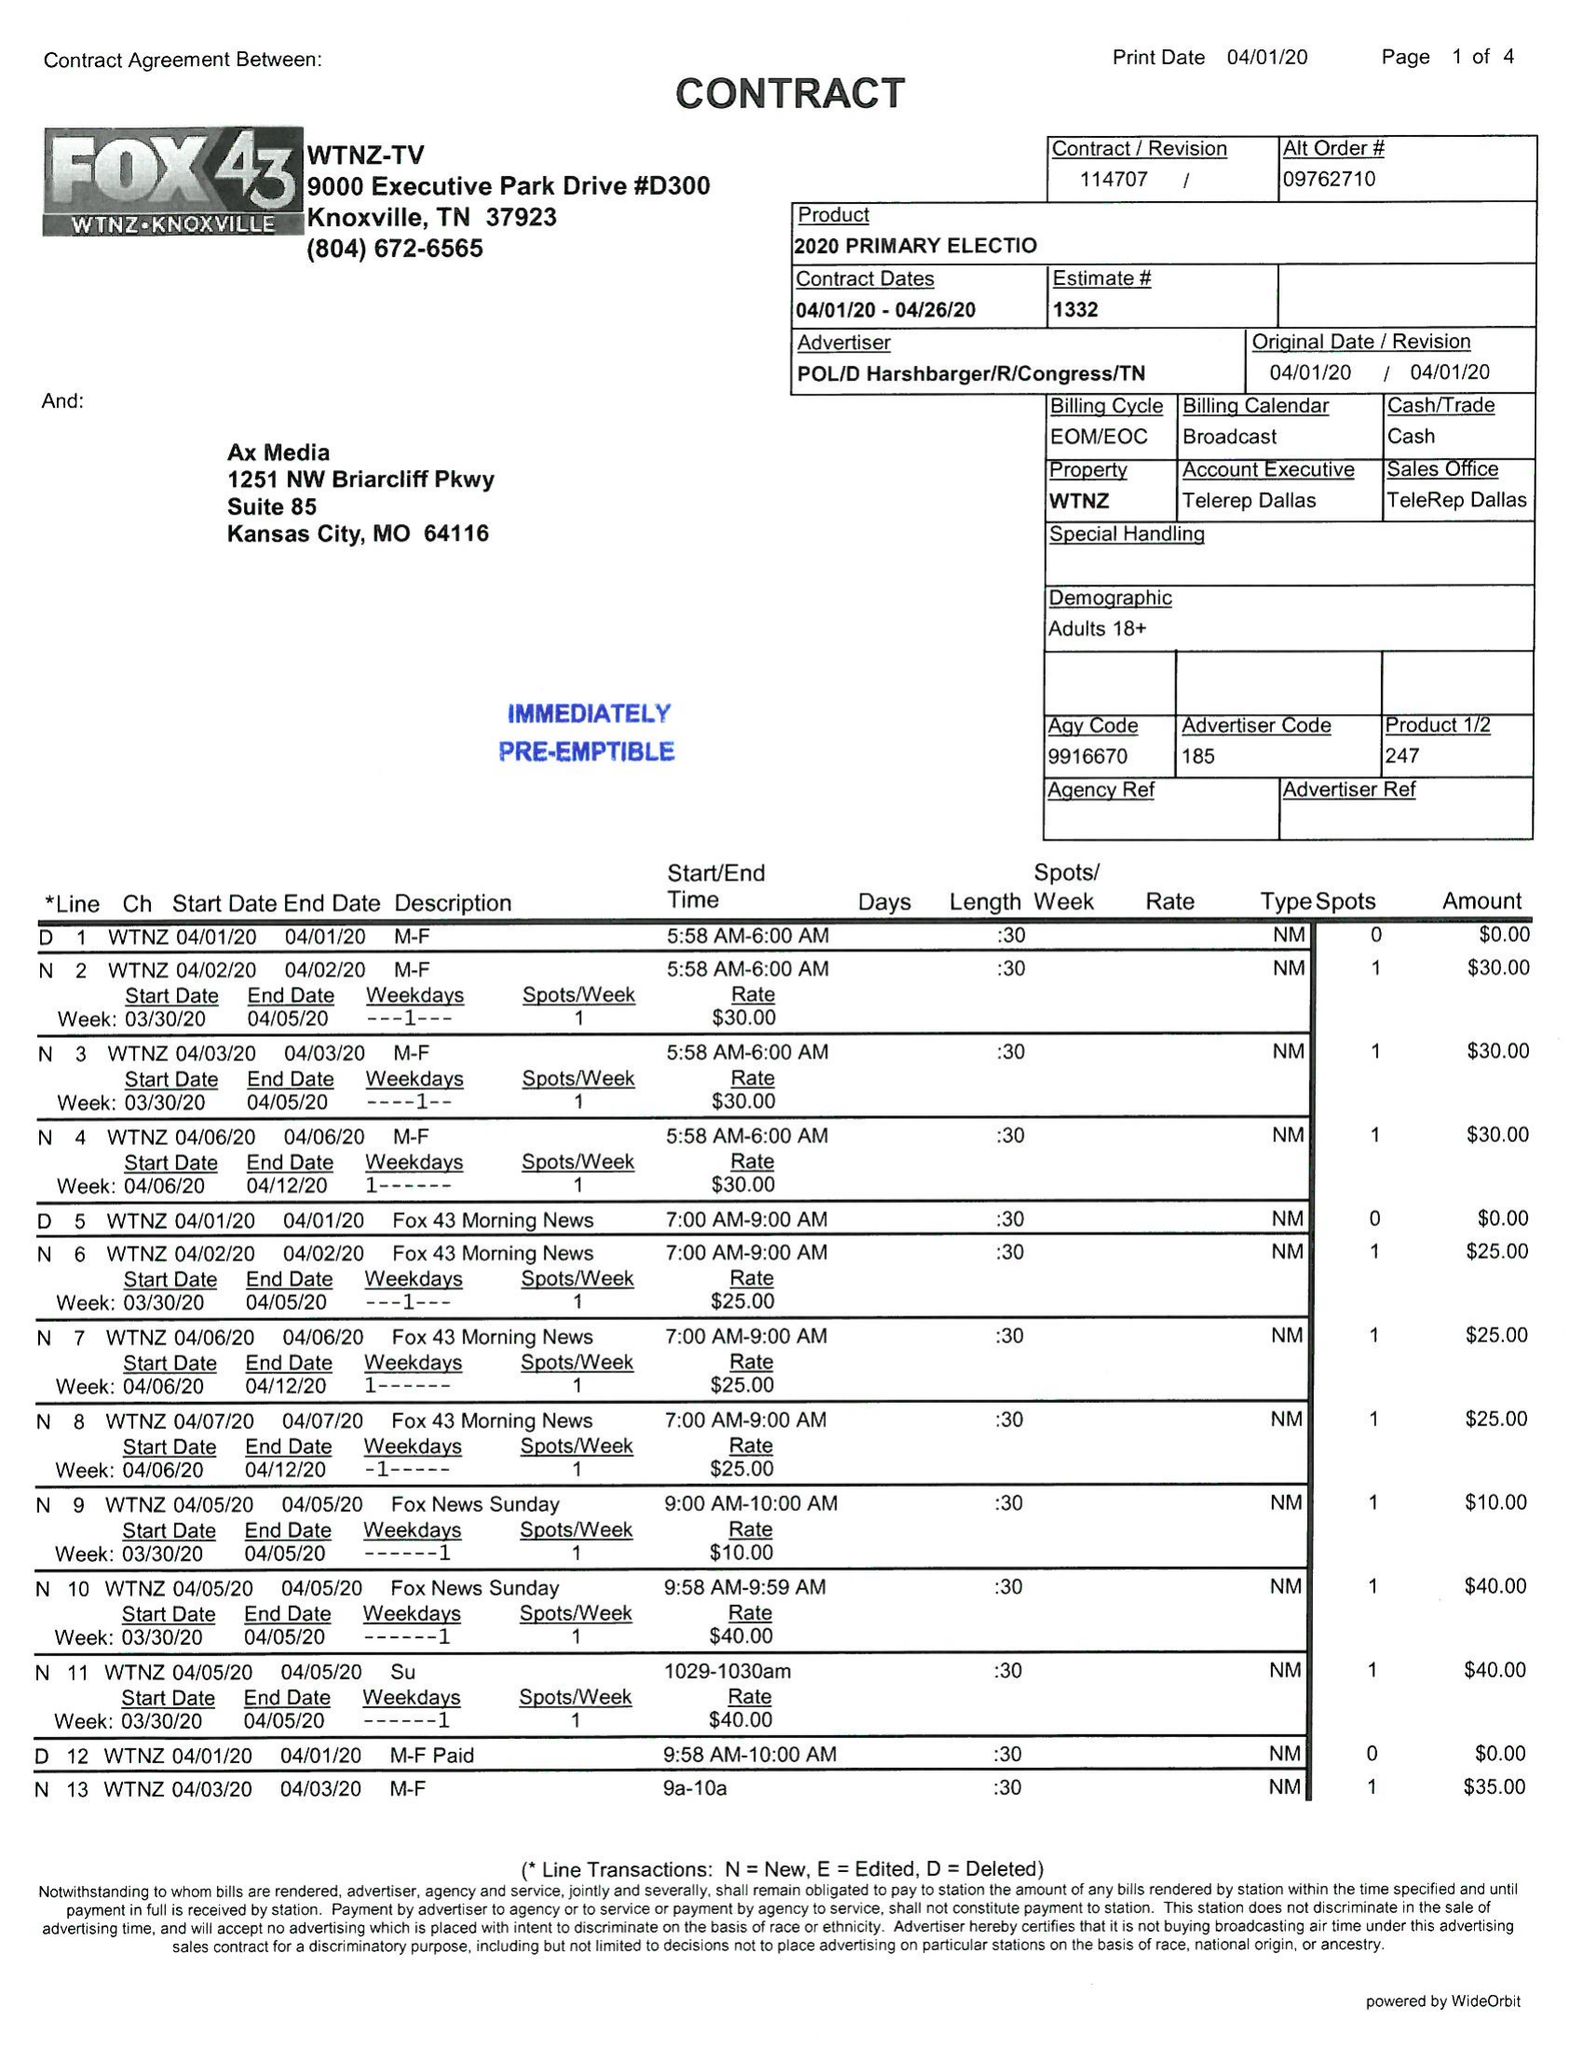What is the value for the flight_to?
Answer the question using a single word or phrase. 04/26/20 